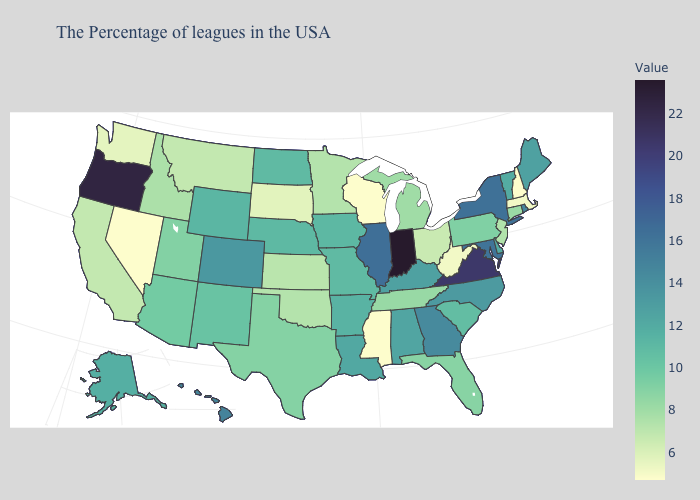Among the states that border North Dakota , does Minnesota have the lowest value?
Write a very short answer. No. Which states hav the highest value in the West?
Concise answer only. Oregon. Does the map have missing data?
Write a very short answer. No. Among the states that border Georgia , does Tennessee have the highest value?
Answer briefly. No. Which states have the lowest value in the USA?
Quick response, please. New Hampshire, Wisconsin, Mississippi, Nevada. Which states have the lowest value in the USA?
Concise answer only. New Hampshire, Wisconsin, Mississippi, Nevada. 